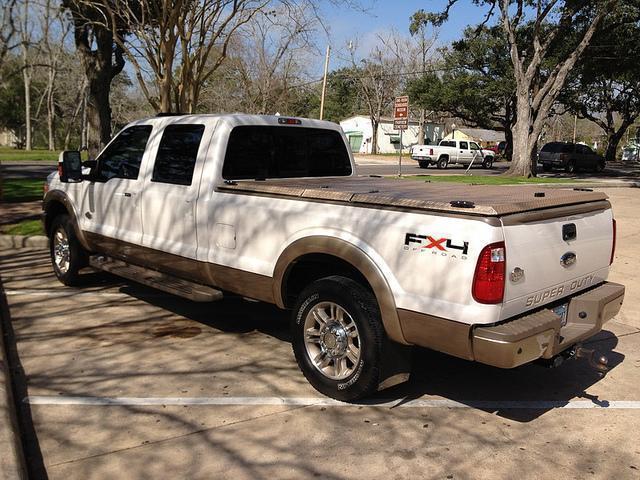What is the cover on the back of the truck called?
Select the accurate answer and provide justification: `Answer: choice
Rationale: srationale.`
Options: Blanket, tarp, hood, tonneau cover. Answer: tonneau cover.
Rationale: A piece that protects anything in the back of the truck. 